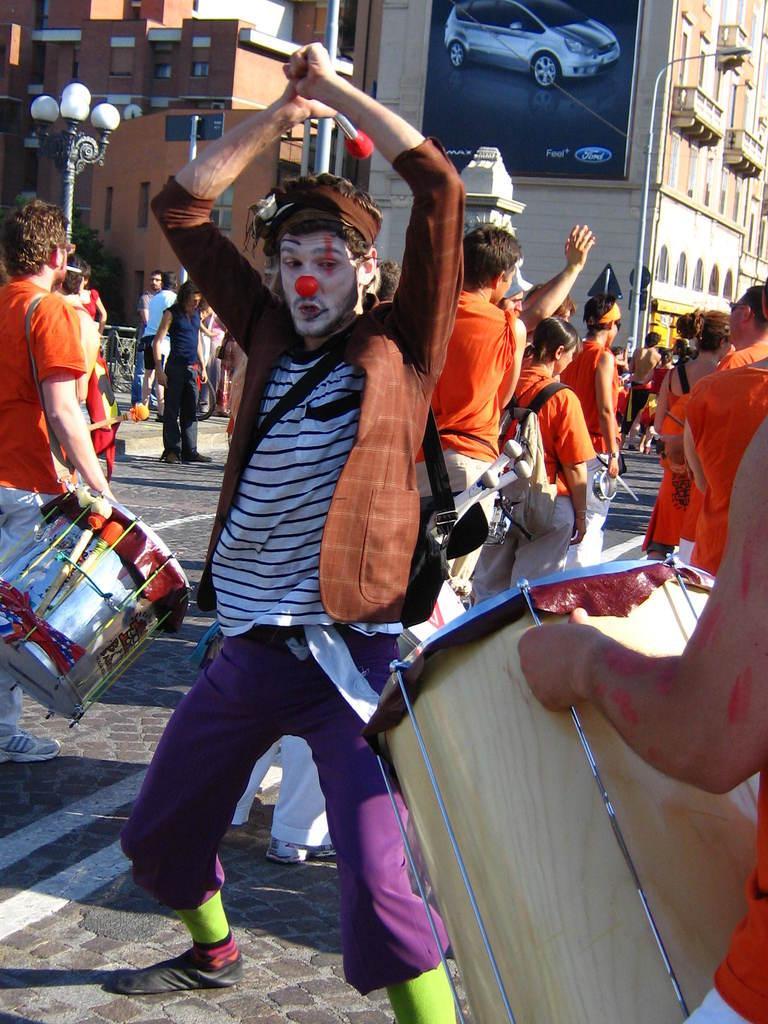Could you give a brief overview of what you see in this image? The person wearing a brown jacket is holding a drumstick in his hand and there are group of people wearing orange shirts in background and there are two buildings were one building has ford car picture on it and the other building is red in color. 